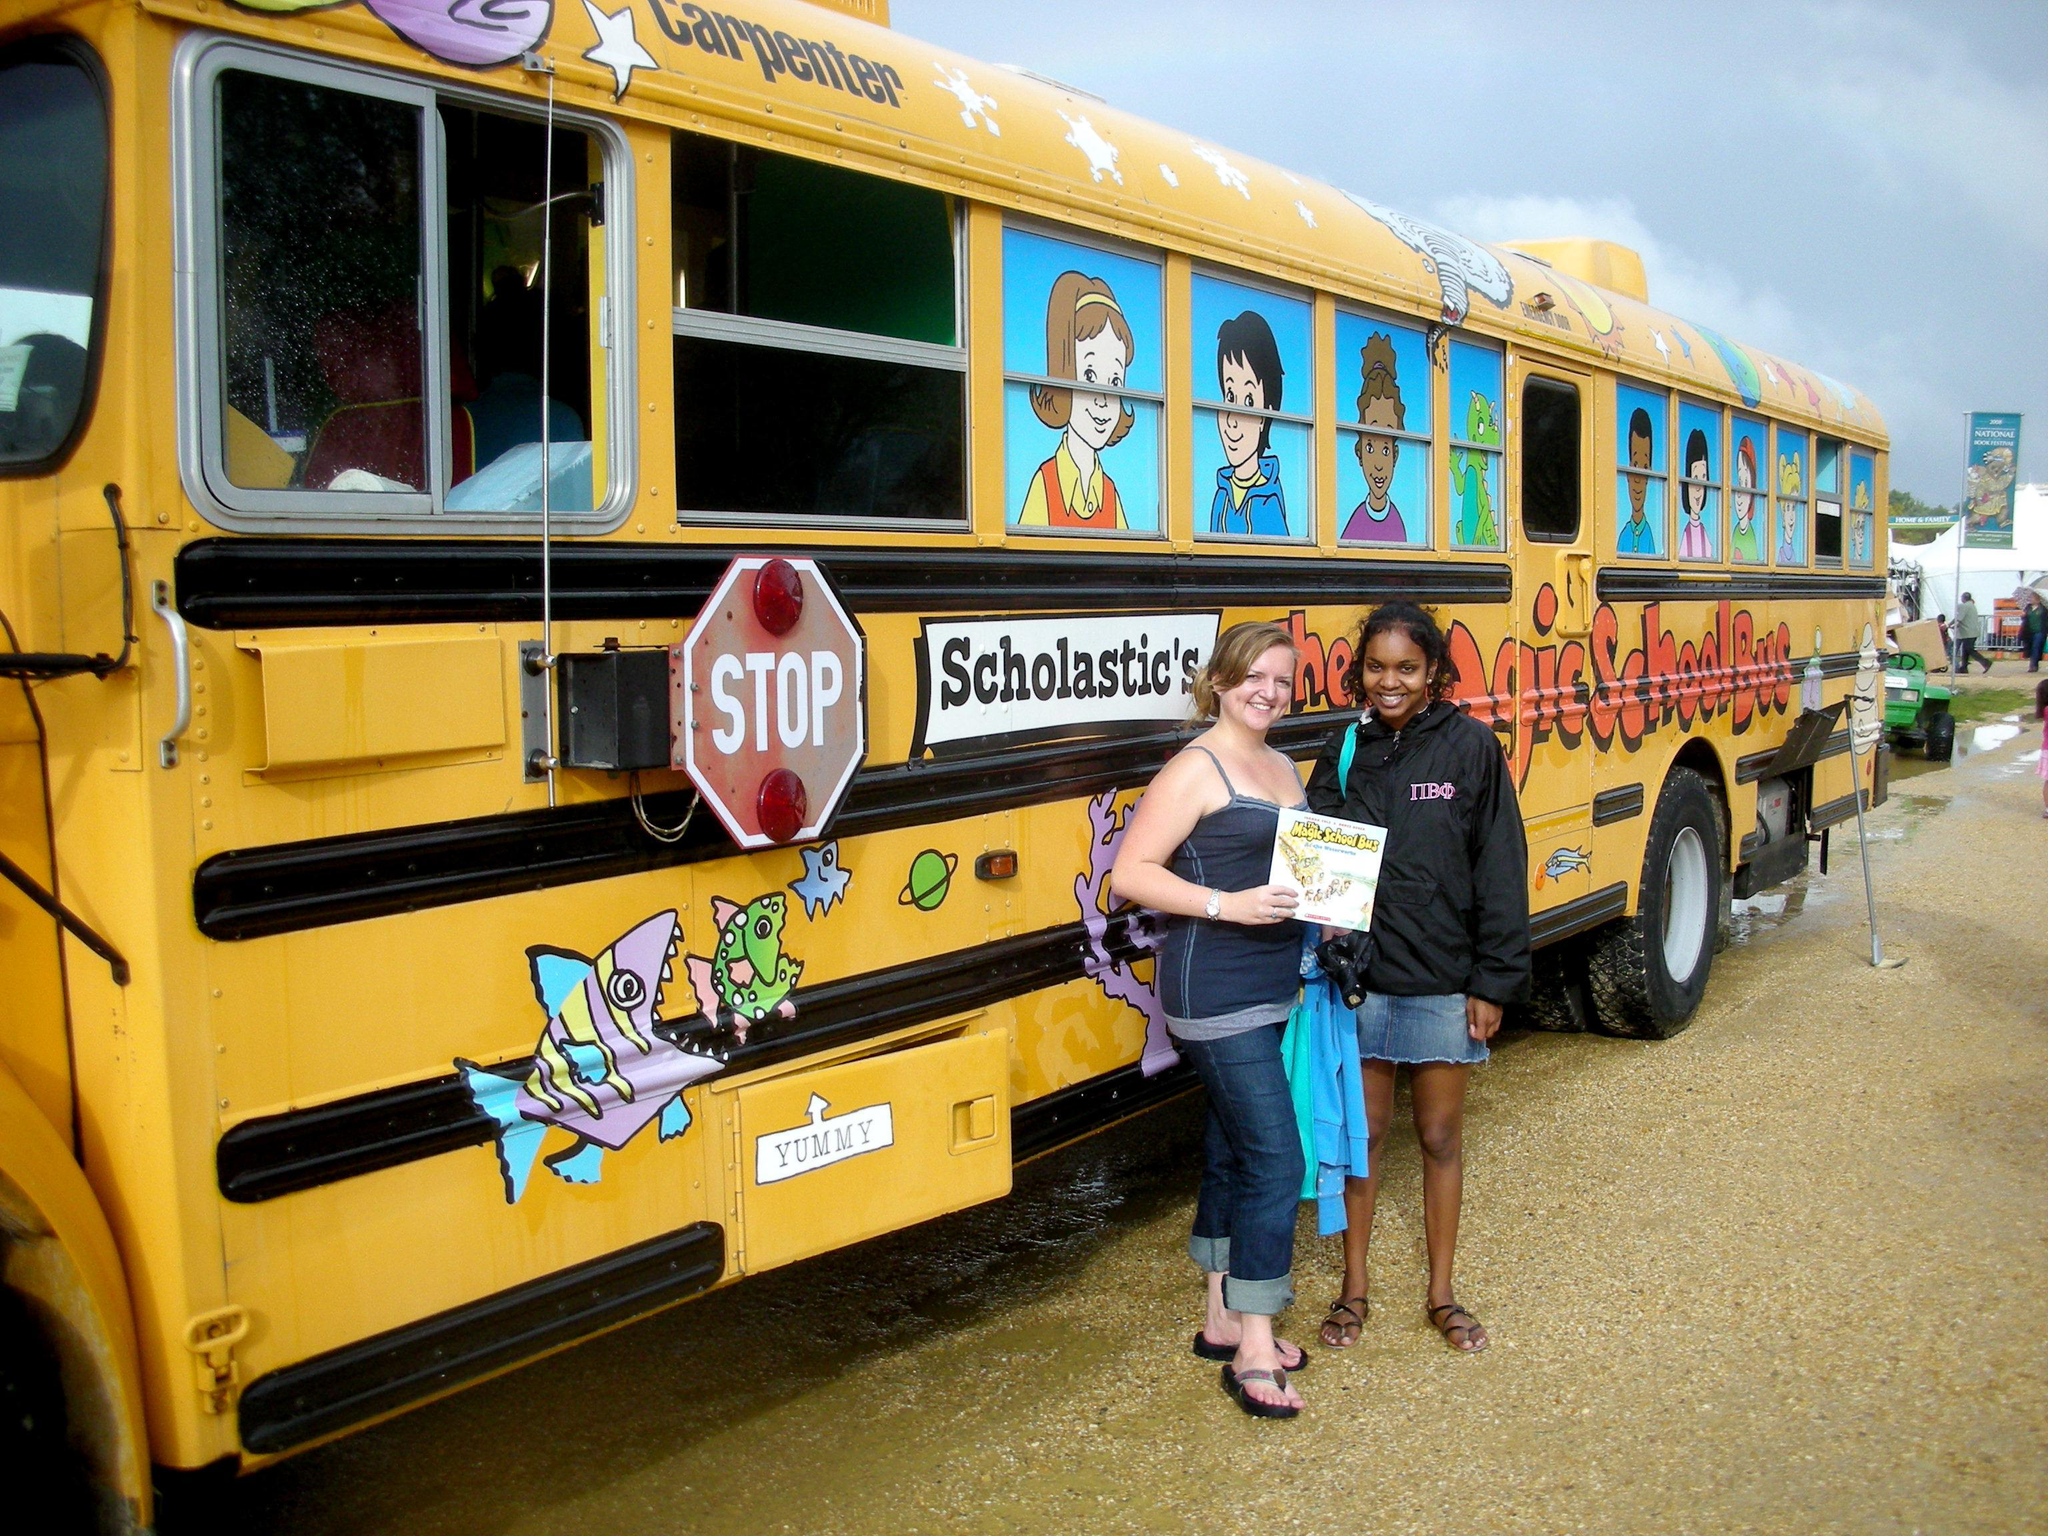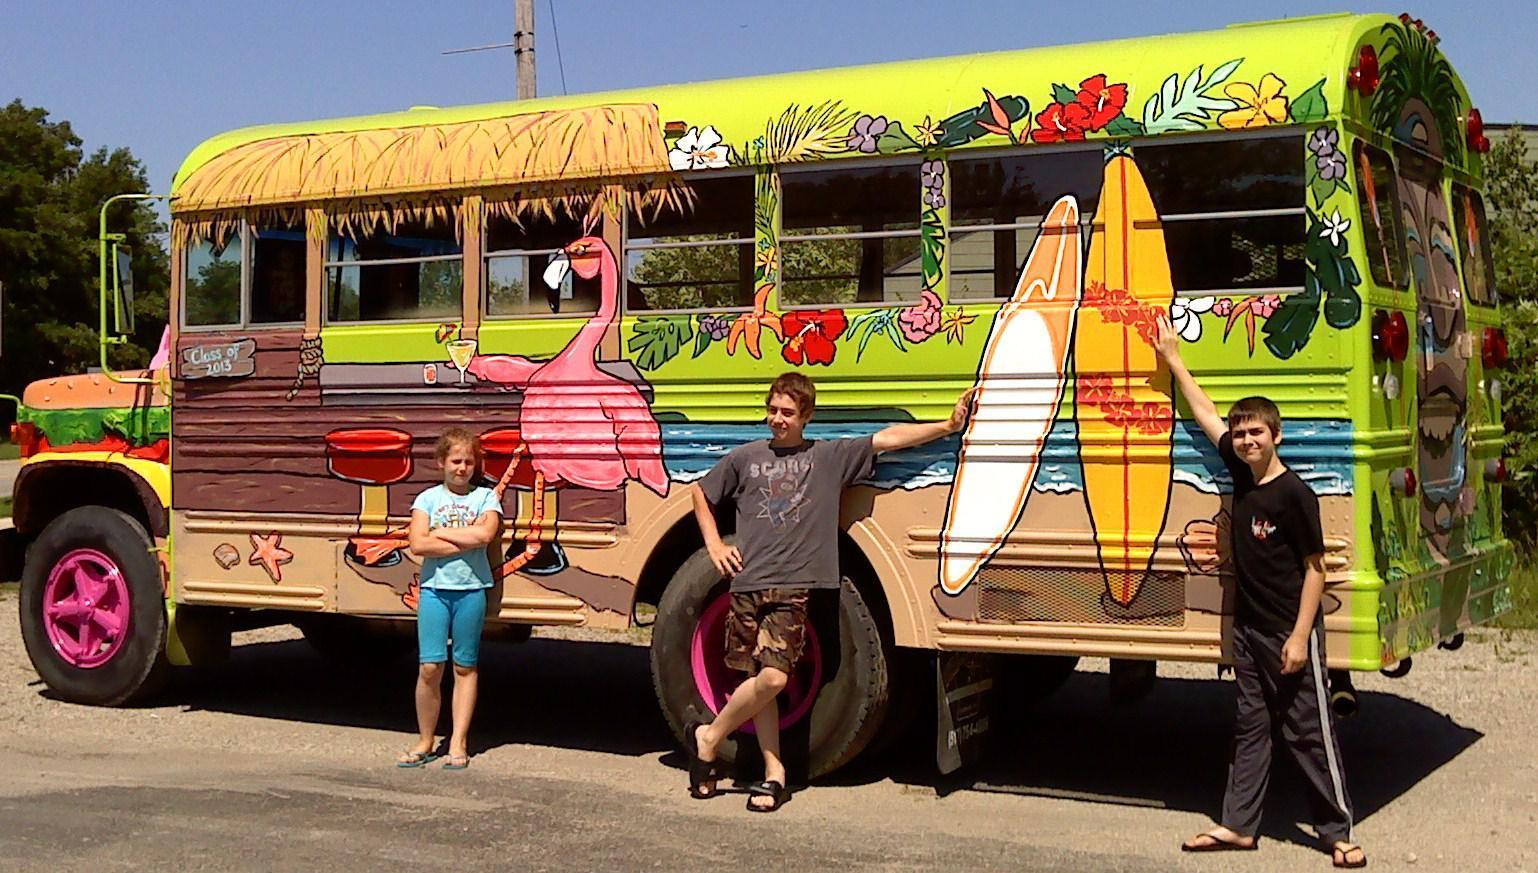The first image is the image on the left, the second image is the image on the right. For the images displayed, is the sentence "One bus is a Magic School Bus and one isn't." factually correct? Answer yes or no. Yes. The first image is the image on the left, the second image is the image on the right. Given the left and right images, does the statement "An image includes a girl in jeans standing in front of a bus decorated with cartoon faces in the windows." hold true? Answer yes or no. Yes. 